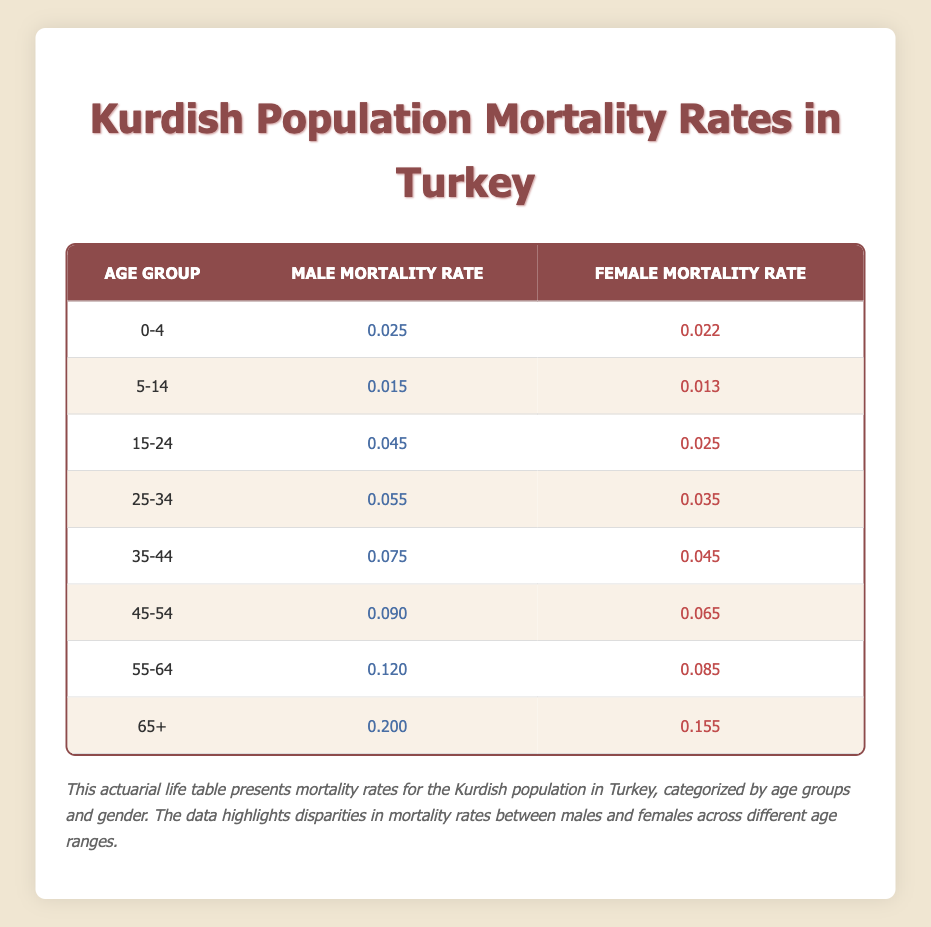What is the male mortality rate for the age group 25-34? According to the table, the male mortality rate for the age group 25-34 is listed directly in the corresponding row under "Male Mortality Rate." It shows a value of 0.055.
Answer: 0.055 What is the female mortality rate for the age group 55-64? The table shows the female mortality rate for the 55-64 age group in the designated row. It states the rate as 0.085.
Answer: 0.085 Which age group has the highest male mortality rate? To find the highest male mortality rate, we examine all male mortality values across the age groups. The maximum value appears in the 65+ age group at 0.200.
Answer: 65+ Is the female mortality rate higher in the age group 45-54 compared to 35-44? By comparing the female mortality rates in the table, we see the rate for 45-54 is 0.065 and for 35-44 is 0.045. Since 0.065 is greater than 0.045, the statement is true.
Answer: Yes What is the average male mortality rate for the age groups 0-4 and 5-14? The male mortality rates for age groups 0-4 and 5-14 are 0.025 and 0.015, respectively. Summing these gives 0.025 + 0.015 = 0.040. Dividing by 2 provides the average: 0.040 / 2 = 0.020.
Answer: 0.020 What is the difference in mortality rates between males and females for the age group 15-24? The male mortality rate for 15-24 is 0.045, while the female rate is 0.025. To find the difference, we subtract 0.025 from 0.045, resulting in a difference of 0.020.
Answer: 0.020 Is the mortality rate for females over 65 years old lower than the rate for males in the same age group? The table shows the female mortality rate for 65+ is 0.155 and the male rate is 0.200. Since 0.155 is less than 0.200, the statement is true.
Answer: Yes Which gender has a higher mortality rate in the age group 45-54, and by how much? In the 45-54 age group, the male mortality rate is 0.090, and the female rate is 0.065. To find the difference, we subtract 0.065 from 0.090, which equals 0.025, denoting that males have a higher rate.
Answer: Males; 0.025 What is the total male mortality rate for the age groups 0-4, 5-14, and 15-24? The male mortality rates for the age groups 0-4, 5-14, and 15-24 are 0.025, 0.015, and 0.045, respectively. Adding those rates gives a total of 0.025 + 0.015 + 0.045 = 0.085.
Answer: 0.085 